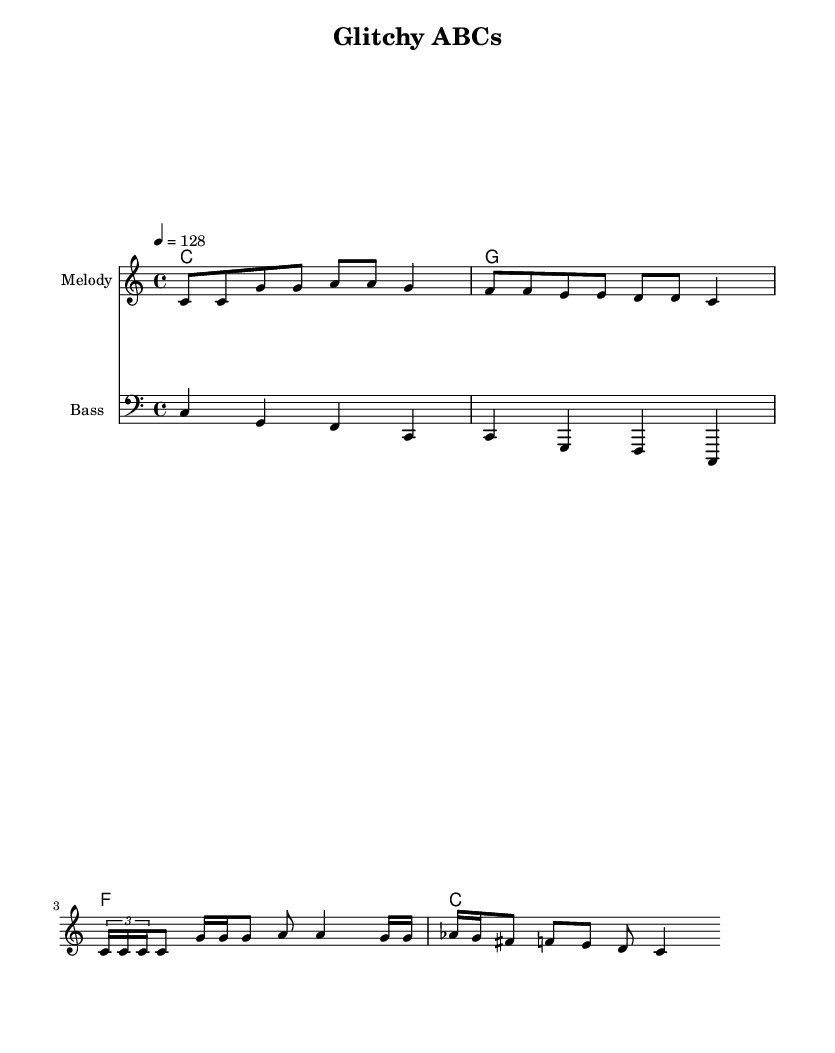What is the key signature of this music? The key signature is C major, which has no sharps or flats indicated at the beginning of the staff.
Answer: C major What is the time signature of this music? The time signature appears at the beginning of the score and is represented as 4/4, meaning there are four beats in each measure and the quarter note gets one beat.
Answer: 4/4 What is the tempo of this piece? The tempo marking shows a tempo of 128, indicating that there are 128 beats per minute, which is typically indicated at the start of the score.
Answer: 128 How many measures are in the melody? By counting the measures of the melody line displayed in the sheet music, there are a total of five measures shown.
Answer: 5 What instruments are included in this score? The score includes a melody staff and a bass staff, representing the two main instrumental parts of the arrangement.
Answer: Melody and Bass Which chord is played at measure 2? The chord name above the measure indicates the chord played, which is G, as shown in the chord mode section of the score.
Answer: G What type of music is this piece classified as? The characteristics of the music, such as the use of glitch elements and modern rhythmic structure, indicate it falls into the category of Electronic music.
Answer: Electronic 